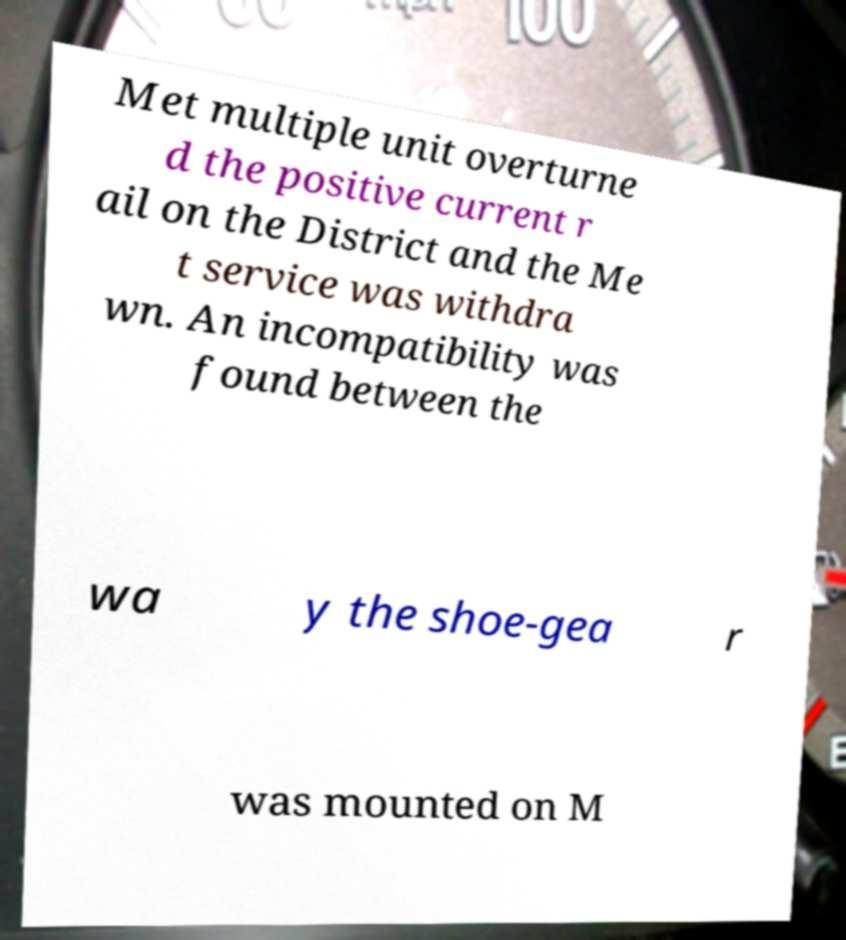Could you assist in decoding the text presented in this image and type it out clearly? Met multiple unit overturne d the positive current r ail on the District and the Me t service was withdra wn. An incompatibility was found between the wa y the shoe-gea r was mounted on M 